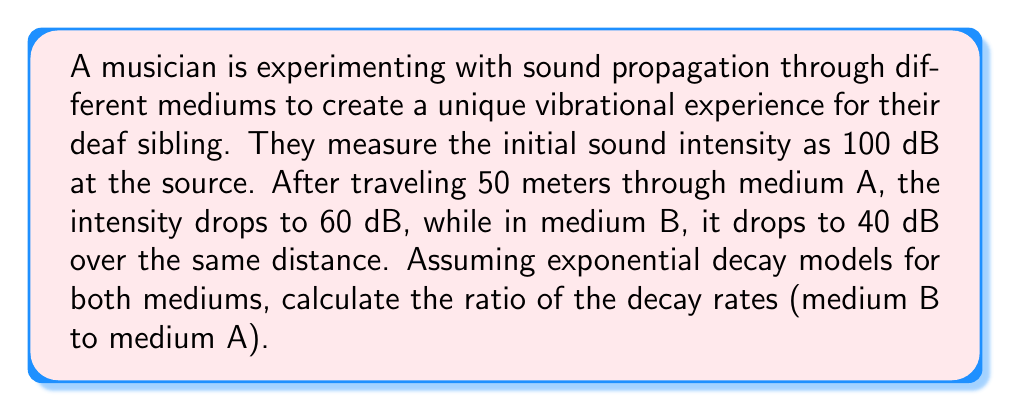Provide a solution to this math problem. Let's approach this step-by-step:

1) The exponential decay model for sound intensity is given by:
   $$I = I_0 e^{-kx}$$
   where $I$ is the final intensity, $I_0$ is the initial intensity, $k$ is the decay rate, and $x$ is the distance.

2) We can convert this to decibels using the relation:
   $$dB = 10 \log_{10}(\frac{I}{I_0})$$

3) Substituting the exponential model into the decibel equation:
   $$dB = 10 \log_{10}(e^{-kx}) = -10kx \log_{10}(e)$$

4) For medium A:
   $$60 - 100 = -10k_A(50)\log_{10}(e)$$
   $$-40 = -500k_A\log_{10}(e)$$
   $$k_A = \frac{40}{500\log_{10}(e)} = 0.0184$$

5) For medium B:
   $$40 - 100 = -10k_B(50)\log_{10}(e)$$
   $$-60 = -500k_B\log_{10}(e)$$
   $$k_B = \frac{60}{500\log_{10}(e)} = 0.0276$$

6) The ratio of decay rates (medium B to medium A) is:
   $$\frac{k_B}{k_A} = \frac{0.0276}{0.0184} = 1.5$$
Answer: 1.5 